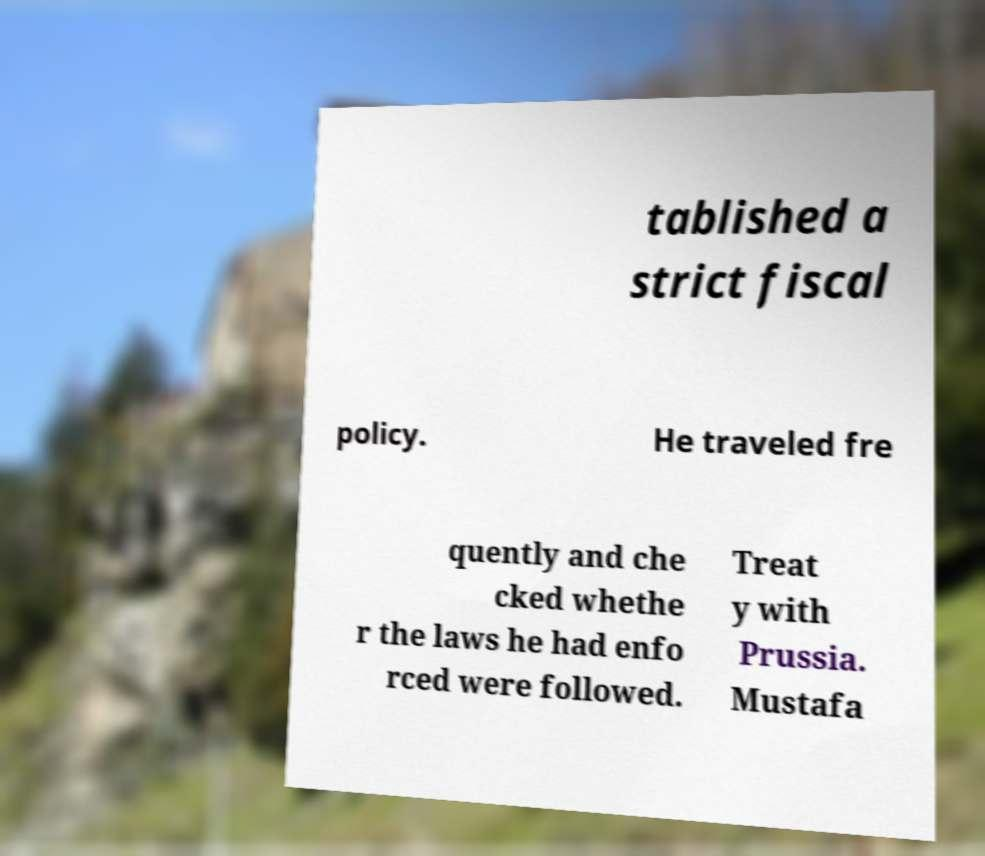Could you assist in decoding the text presented in this image and type it out clearly? tablished a strict fiscal policy. He traveled fre quently and che cked whethe r the laws he had enfo rced were followed. Treat y with Prussia. Mustafa 